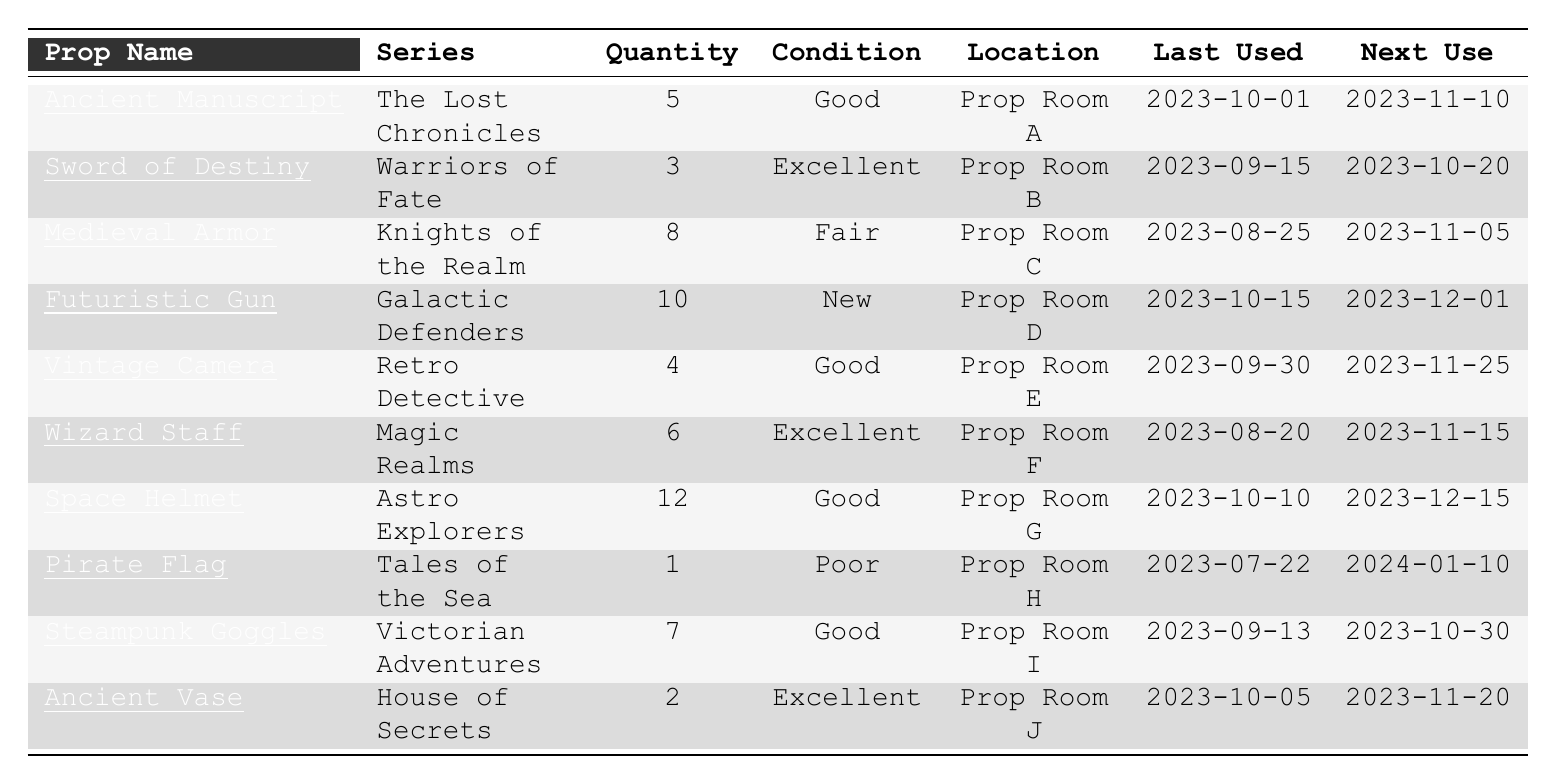What is the quantity of the "Wizard Staff"? Referring to the row for "Wizard Staff" in the table, it shows a quantity of 6, which indicates how many are available.
Answer: 6 What is the condition of the "Pirate Flag"? Looking at the row for the "Pirate Flag," the condition is listed as "Poor."
Answer: Poor Which prop has the highest quantity? By comparing the quantities listed, the "Space Helmet" has the highest quantity at 12, more than any other prop.
Answer: Space Helmet How many props have a condition of "Good"? Counting the rows with a condition of "Good," there are 4 props: "Ancient Manuscript," "Vintage Camera," "Space Helmet," and "Steampunk Goggles."
Answer: 4 What series does the "Ancient Vase" belong to? The table lists the "Ancient Vase" under the series titled "House of Secrets."
Answer: House of Secrets What is the last used date for "Futuristic Gun"? Checking the "Futuristic Gun" row shows it was last used on "2023-10-15."
Answer: 2023-10-15 How many props are in "Prop Room A"? In the table, only one prop, the "Ancient Manuscript," is listed under "Prop Room A."
Answer: 1 What condition is the "Medieval Armor" in? The table shows that the condition of "Medieval Armor" is "Fair."
Answer: Fair When is the "Next Use" date for the "Steampunk Goggles"? Referring to the "Steampunk Goggles" row, the next use is scheduled for "2023-10-30."
Answer: 2023-10-30 Which prop has the least quantity, and how many are there? The "Pirate Flag" has the least quantity at 1, as seen in its row.
Answer: Pirate Flag, 1 How many props are scheduled for next use in November 2023? The props scheduled for next use in November 2023 are "Ancient Manuscript," "Medieval Armor," "Vintage Camera," "Wizard Staff," and "Ancient Vase," totaling 5.
Answer: 5 Is there any prop that is in "New" condition? Yes, the "Futuristic Gun" is listed as being in "New" condition.
Answer: Yes Calculate the total quantity of props across all series. Adding all quantities together: 5 + 3 + 8 + 10 + 4 + 6 + 12 + 1 + 7 + 2 = 58.
Answer: 58 How many props are located in "Prop Room F"? The table shows only one prop, "Wizard Staff," is listed in "Prop Room F."
Answer: 1 What series features the "Space Helmet"? According to the table, the "Space Helmet" is featured in "Astro Explorers."
Answer: Astro Explorers 